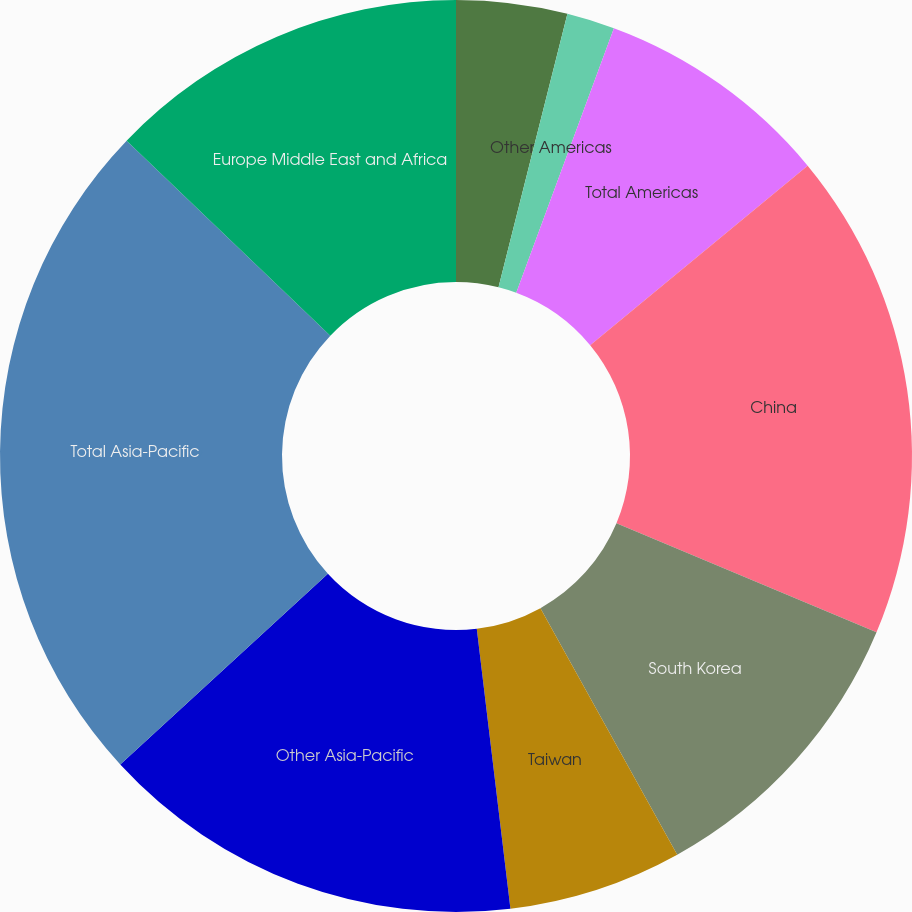Convert chart. <chart><loc_0><loc_0><loc_500><loc_500><pie_chart><fcel>United States<fcel>Other Americas<fcel>Total Americas<fcel>China<fcel>South Korea<fcel>Taiwan<fcel>Other Asia-Pacific<fcel>Total Asia-Pacific<fcel>Europe Middle East and Africa<nl><fcel>3.93%<fcel>1.7%<fcel>8.39%<fcel>17.31%<fcel>10.62%<fcel>6.16%<fcel>15.08%<fcel>23.99%<fcel>12.85%<nl></chart> 